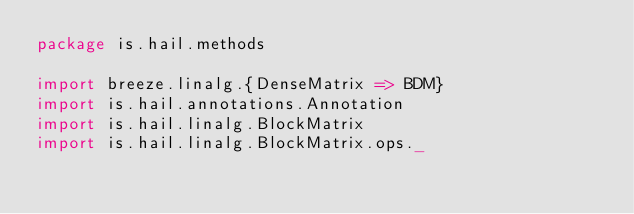Convert code to text. <code><loc_0><loc_0><loc_500><loc_500><_Scala_>package is.hail.methods

import breeze.linalg.{DenseMatrix => BDM}
import is.hail.annotations.Annotation
import is.hail.linalg.BlockMatrix
import is.hail.linalg.BlockMatrix.ops._</code> 